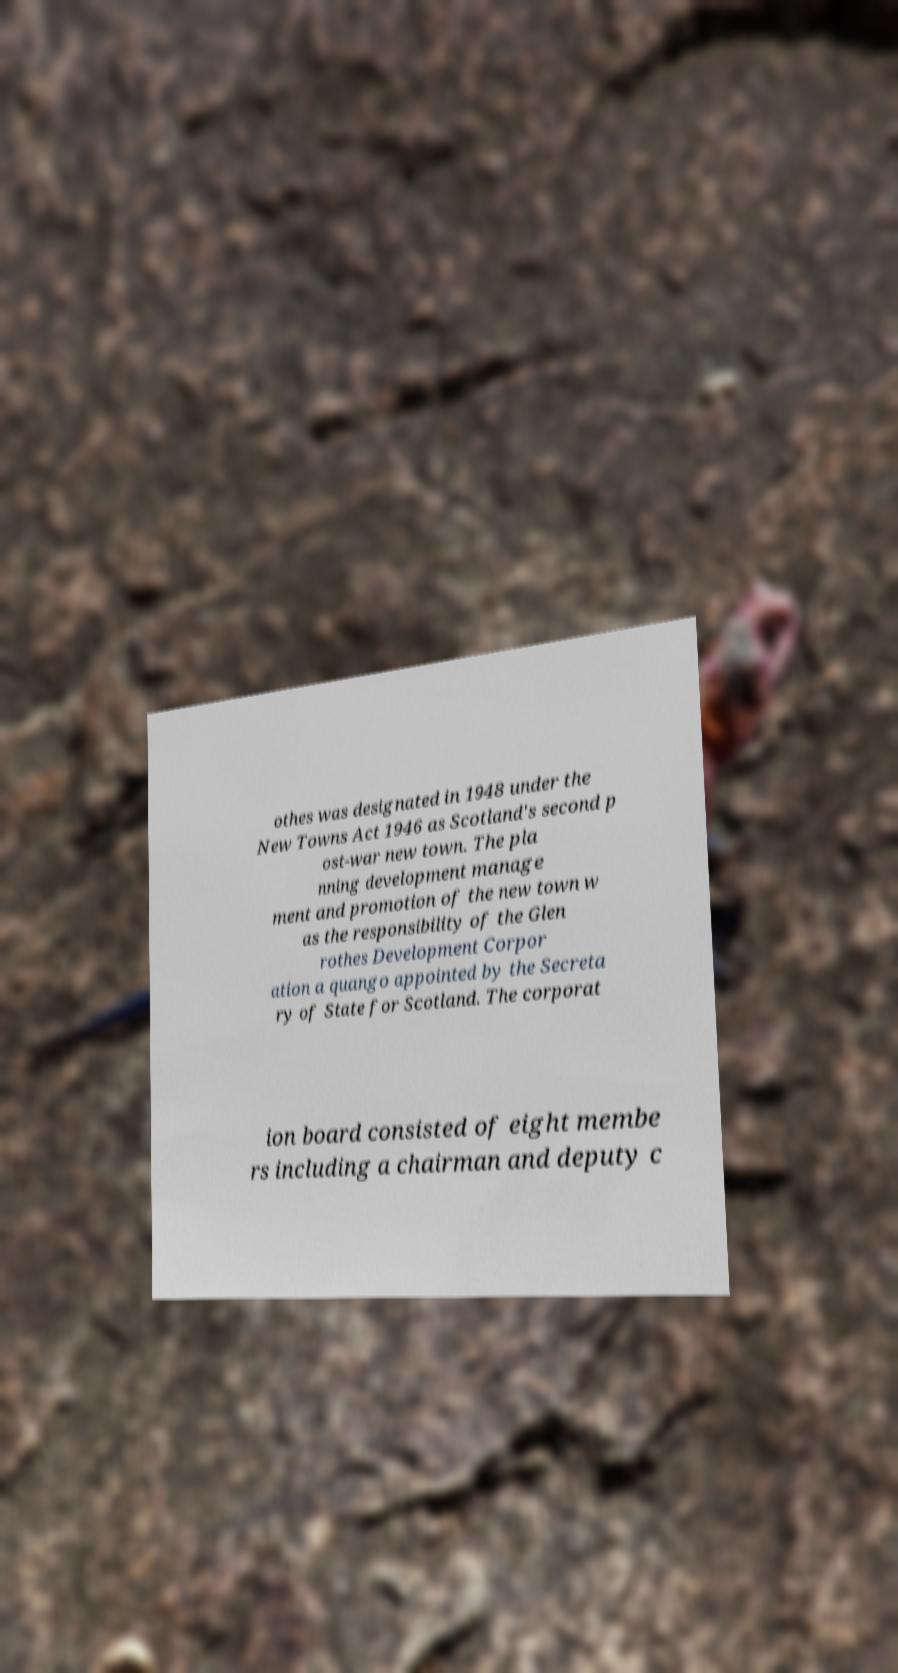There's text embedded in this image that I need extracted. Can you transcribe it verbatim? othes was designated in 1948 under the New Towns Act 1946 as Scotland's second p ost-war new town. The pla nning development manage ment and promotion of the new town w as the responsibility of the Glen rothes Development Corpor ation a quango appointed by the Secreta ry of State for Scotland. The corporat ion board consisted of eight membe rs including a chairman and deputy c 